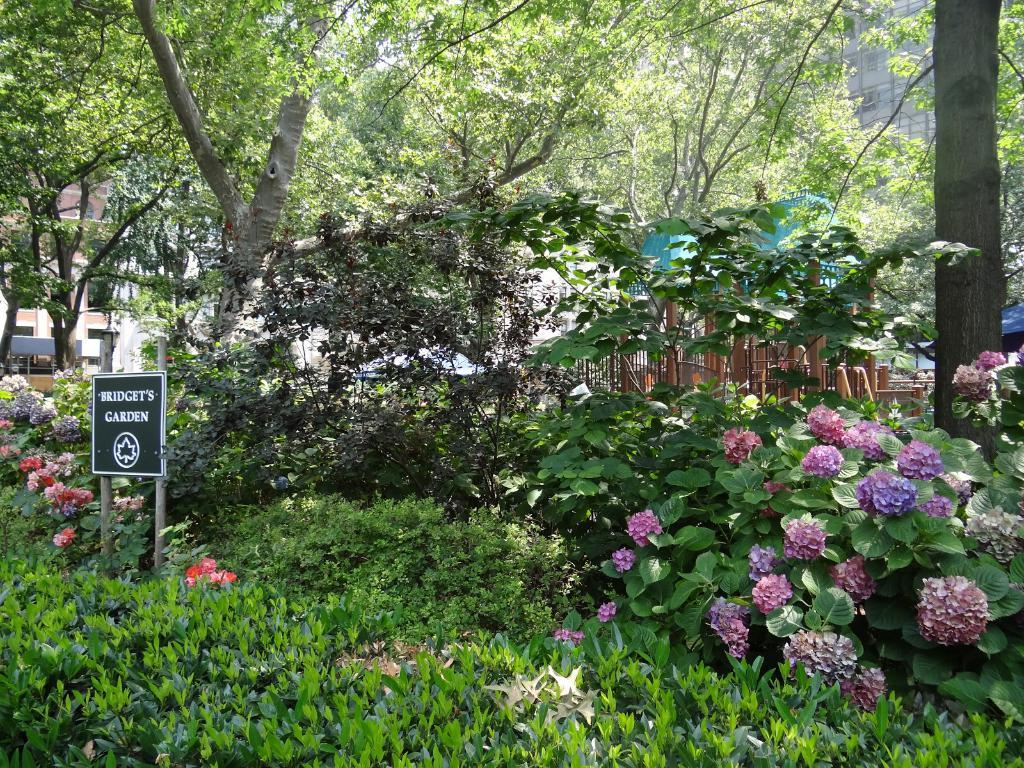What type of vegetation can be seen in the image? There are plants, flowers, and trees in the image. What can be seen in the background of the image? There are buildings in the background of the image. What is located in the center of the image? There is a board with text in the center of the image. Can you see a squirrel climbing on the knee of a person in the image? There is no person or squirrel present in the image. What type of trade is being conducted in the image? There is no trade being conducted in the image; it features plants, flowers, trees, buildings, and a board with text. 